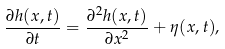Convert formula to latex. <formula><loc_0><loc_0><loc_500><loc_500>\frac { \partial h ( x , t ) } { \partial t } = \frac { \partial ^ { 2 } h ( x , t ) } { \partial x ^ { 2 } } + \eta ( x , t ) ,</formula> 